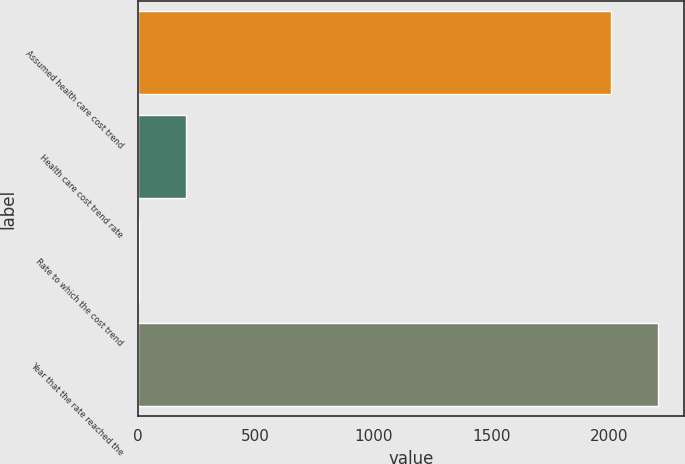Convert chart. <chart><loc_0><loc_0><loc_500><loc_500><bar_chart><fcel>Assumed health care cost trend<fcel>Health care cost trend rate<fcel>Rate to which the cost trend<fcel>Year that the rate reached the<nl><fcel>2005<fcel>205.3<fcel>5<fcel>2205.3<nl></chart> 